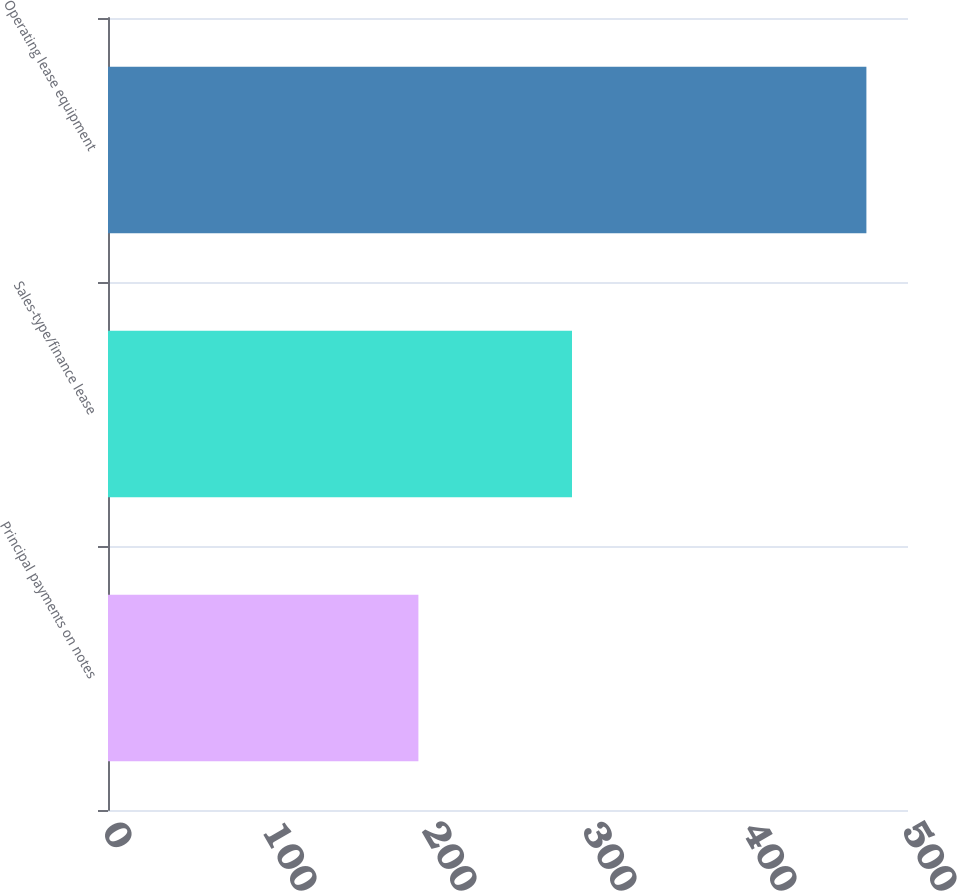Convert chart to OTSL. <chart><loc_0><loc_0><loc_500><loc_500><bar_chart><fcel>Principal payments on notes<fcel>Sales-type/finance lease<fcel>Operating lease equipment<nl><fcel>194<fcel>290<fcel>474<nl></chart> 